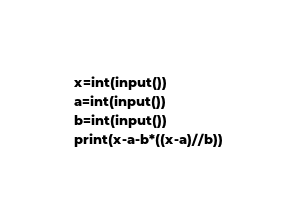Convert code to text. <code><loc_0><loc_0><loc_500><loc_500><_Python_>x=int(input())
a=int(input())
b=int(input())
print(x-a-b*((x-a)//b))</code> 